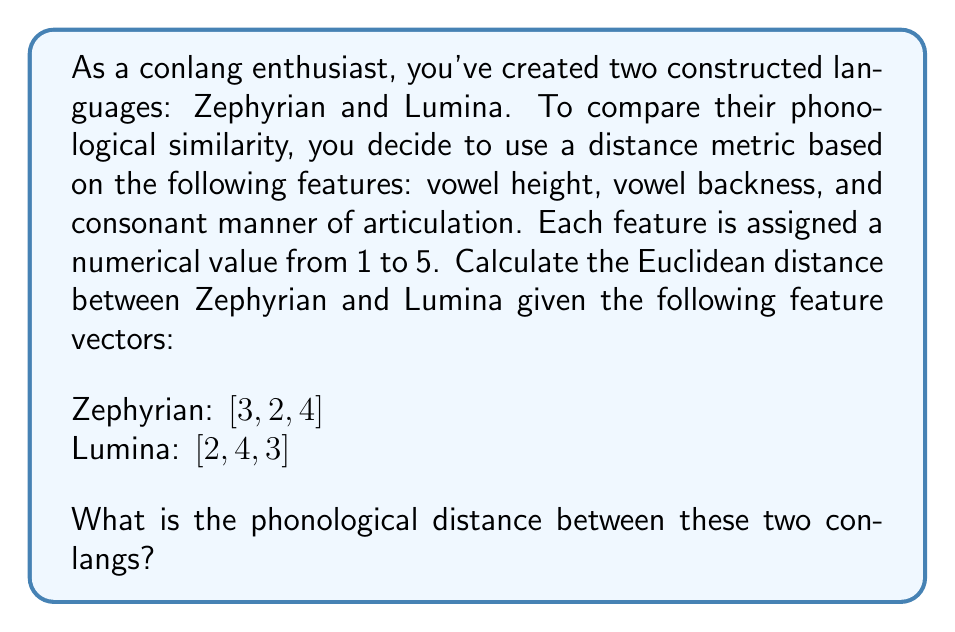Solve this math problem. To calculate the phonological distance between Zephyrian and Lumina, we'll use the Euclidean distance formula in three-dimensional space. The Euclidean distance is defined as:

$$d = \sqrt{(x_1 - y_1)^2 + (x_2 - y_2)^2 + (x_3 - y_3)^2}$$

Where $(x_1, x_2, x_3)$ represents the feature vector of Zephyrian and $(y_1, y_2, y_3)$ represents the feature vector of Lumina.

Let's substitute the values:

1. Vowel height: $x_1 = 3$, $y_1 = 2$
2. Vowel backness: $x_2 = 2$, $y_2 = 4$
3. Consonant manner of articulation: $x_3 = 4$, $y_3 = 3$

Now, let's calculate each term inside the square root:

1. $(x_1 - y_1)^2 = (3 - 2)^2 = 1^2 = 1$
2. $(x_2 - y_2)^2 = (2 - 4)^2 = (-2)^2 = 4$
3. $(x_3 - y_3)^2 = (4 - 3)^2 = 1^2 = 1$

Sum these terms:

$$1 + 4 + 1 = 6$$

Finally, take the square root:

$$d = \sqrt{6} \approx 2.4495$$

This value represents the phonological distance between Zephyrian and Lumina based on the given feature vectors.
Answer: $\sqrt{6} \approx 2.4495$ 